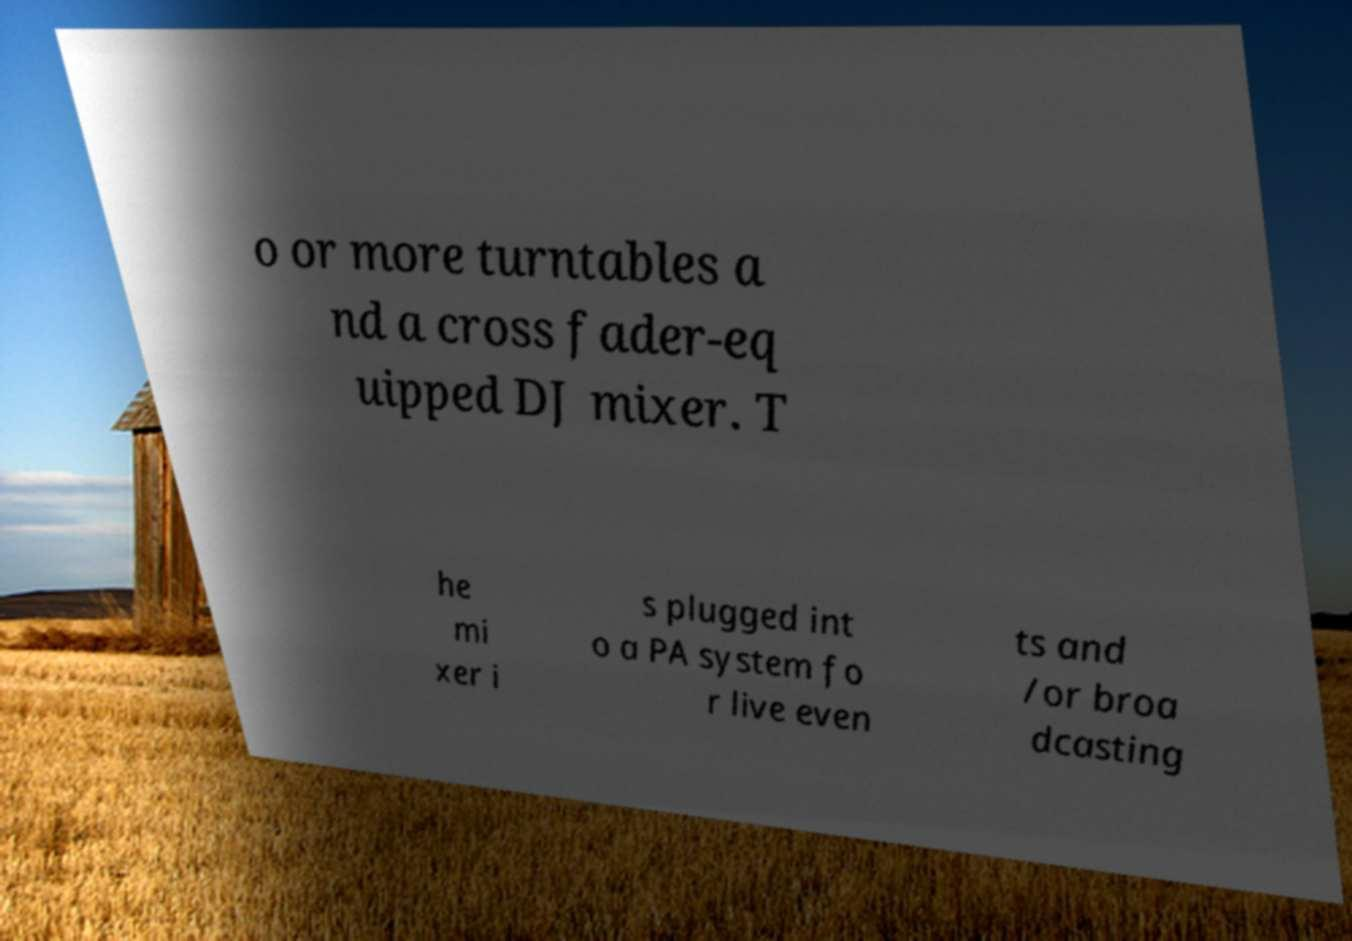Could you extract and type out the text from this image? o or more turntables a nd a cross fader-eq uipped DJ mixer. T he mi xer i s plugged int o a PA system fo r live even ts and /or broa dcasting 